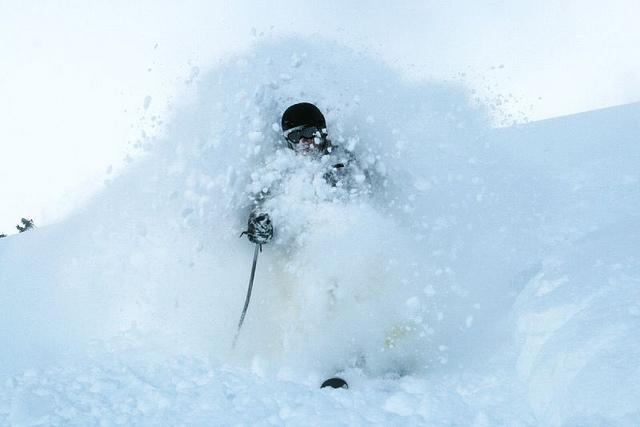What does the skier have on his head?
Short answer required. Hat. Is this an avalanche?
Keep it brief. No. Is the snow in this picture hard packed?
Keep it brief. No. 